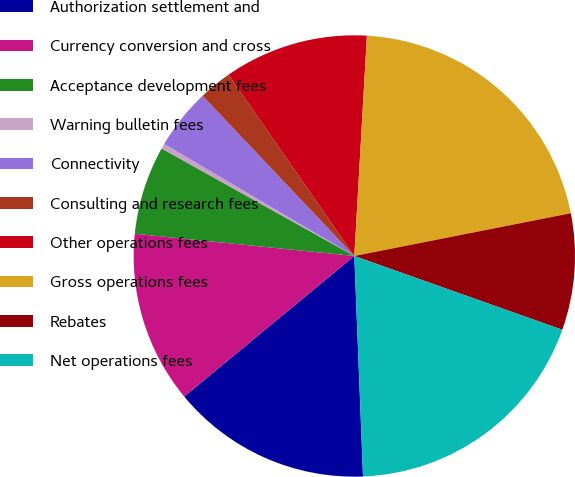Convert chart. <chart><loc_0><loc_0><loc_500><loc_500><pie_chart><fcel>Authorization settlement and<fcel>Currency conversion and cross<fcel>Acceptance development fees<fcel>Warning bulletin fees<fcel>Connectivity<fcel>Consulting and research fees<fcel>Other operations fees<fcel>Gross operations fees<fcel>Rebates<fcel>Net operations fees<nl><fcel>14.64%<fcel>12.6%<fcel>6.49%<fcel>0.38%<fcel>4.45%<fcel>2.42%<fcel>10.56%<fcel>20.99%<fcel>8.53%<fcel>18.95%<nl></chart> 